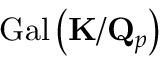Convert formula to latex. <formula><loc_0><loc_0><loc_500><loc_500>{ G a l } \left ( K / Q _ { p } \right )</formula> 